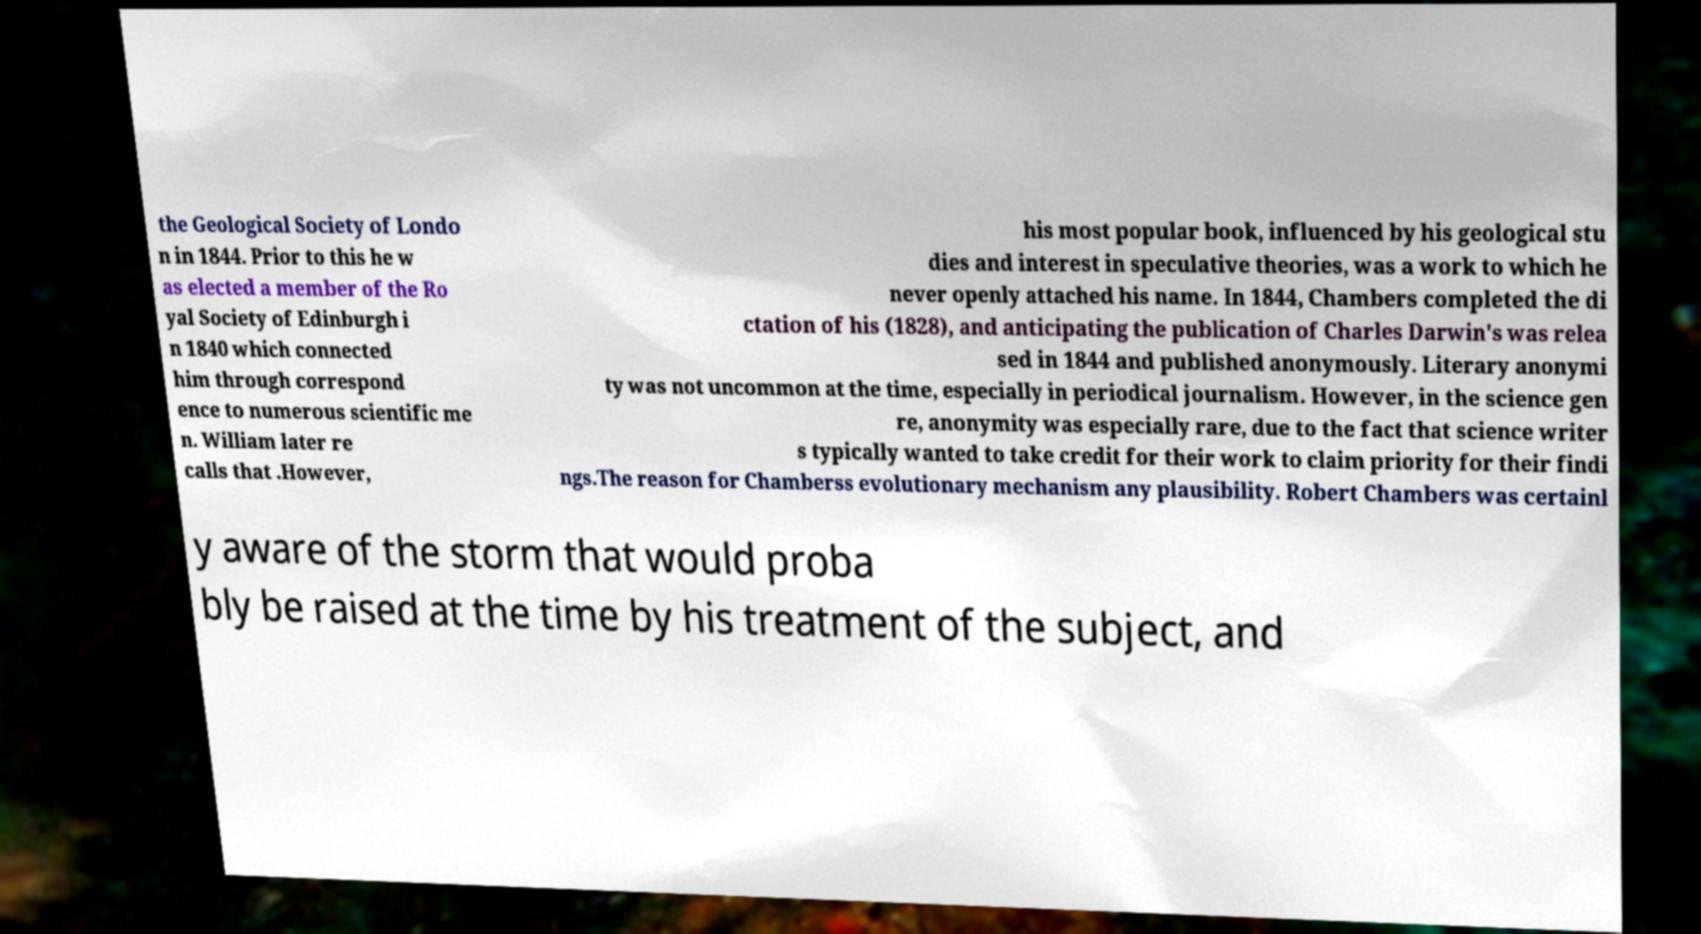Can you read and provide the text displayed in the image?This photo seems to have some interesting text. Can you extract and type it out for me? the Geological Society of Londo n in 1844. Prior to this he w as elected a member of the Ro yal Society of Edinburgh i n 1840 which connected him through correspond ence to numerous scientific me n. William later re calls that .However, his most popular book, influenced by his geological stu dies and interest in speculative theories, was a work to which he never openly attached his name. In 1844, Chambers completed the di ctation of his (1828), and anticipating the publication of Charles Darwin's was relea sed in 1844 and published anonymously. Literary anonymi ty was not uncommon at the time, especially in periodical journalism. However, in the science gen re, anonymity was especially rare, due to the fact that science writer s typically wanted to take credit for their work to claim priority for their findi ngs.The reason for Chamberss evolutionary mechanism any plausibility. Robert Chambers was certainl y aware of the storm that would proba bly be raised at the time by his treatment of the subject, and 